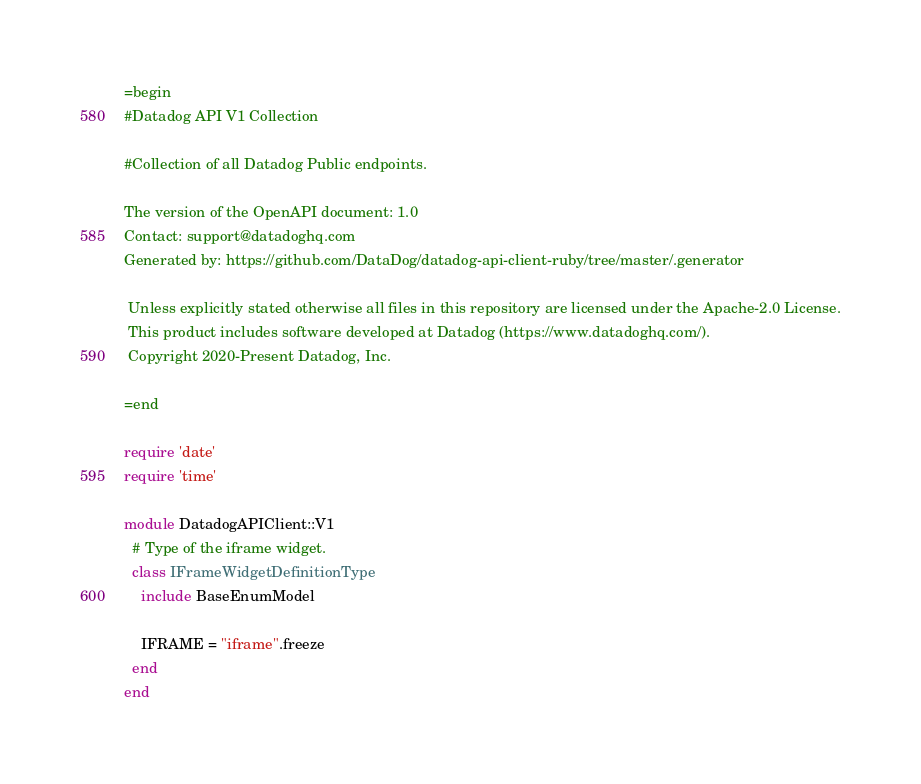Convert code to text. <code><loc_0><loc_0><loc_500><loc_500><_Ruby_>=begin
#Datadog API V1 Collection

#Collection of all Datadog Public endpoints.

The version of the OpenAPI document: 1.0
Contact: support@datadoghq.com
Generated by: https://github.com/DataDog/datadog-api-client-ruby/tree/master/.generator

 Unless explicitly stated otherwise all files in this repository are licensed under the Apache-2.0 License.
 This product includes software developed at Datadog (https://www.datadoghq.com/).
 Copyright 2020-Present Datadog, Inc.

=end

require 'date'
require 'time'

module DatadogAPIClient::V1
  # Type of the iframe widget.
  class IFrameWidgetDefinitionType
    include BaseEnumModel

    IFRAME = "iframe".freeze
  end
end
</code> 